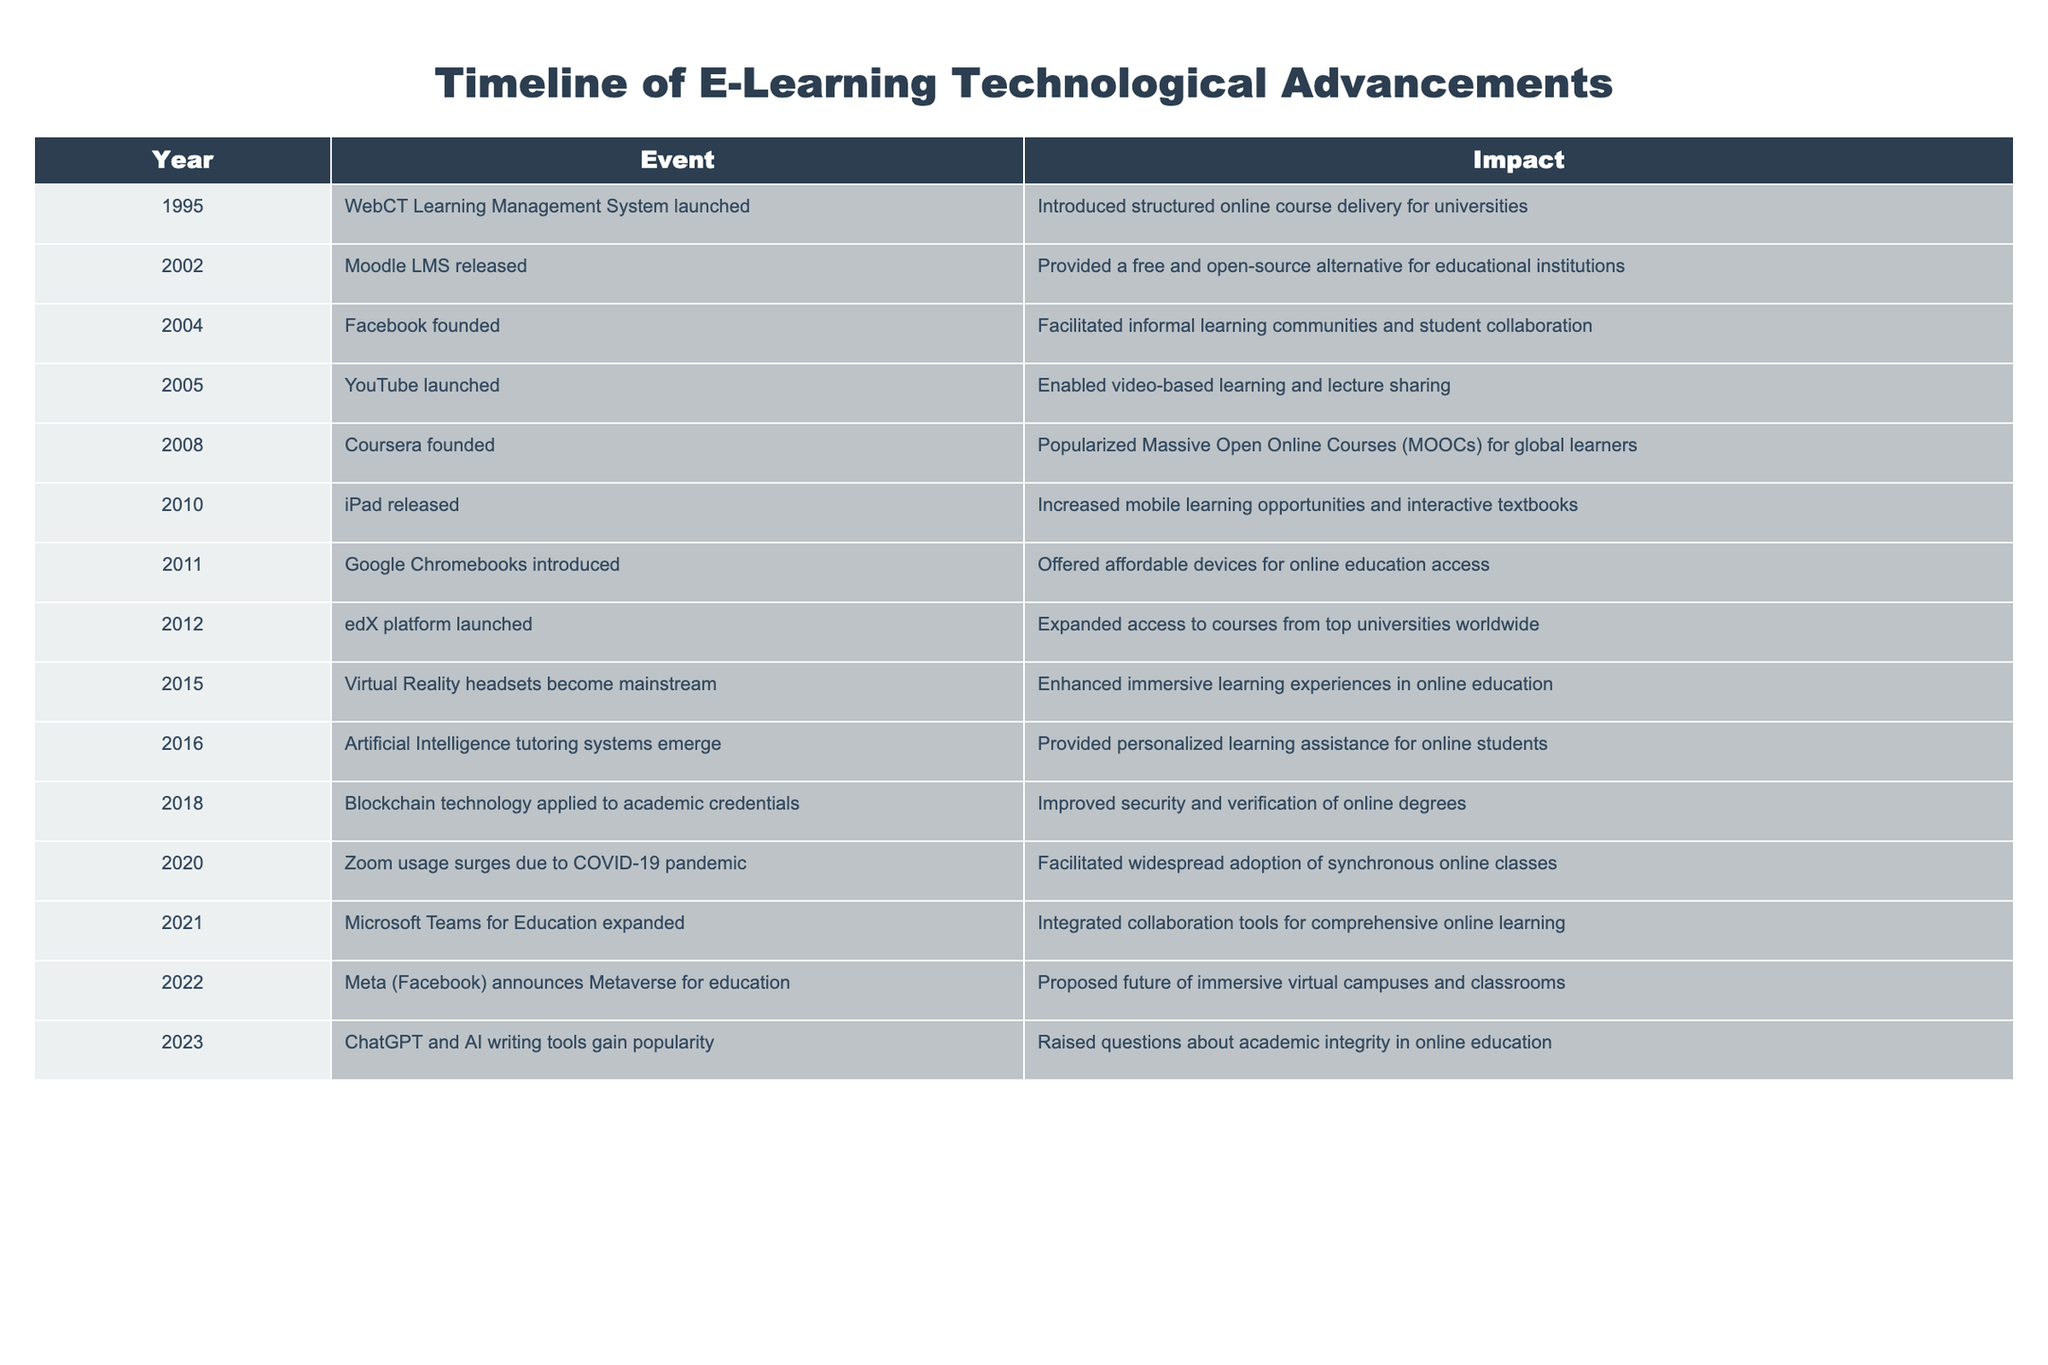What year was the WebCT Learning Management System launched? According to the table, the WebCT Learning Management System was launched in 1995. This is found in the 'Year' column where 'WebCT Learning Management System launched' appears in the 'Event' column.
Answer: 1995 Which event marked the popularization of MOOCs? The event that marked the popularization of MOOCs was the founding of Coursera in 2008. This can be identified in the year 2008, where 'Coursera founded' is listed as the event.
Answer: 2008 How many events occurred that enhanced immersive learning experiences? There are two events related to enhancing immersive learning experiences: in 2015, Virtual Reality headsets became mainstream, and in 2022, Meta announced Metaverse for education. Therefore, I count these two events listed under 'Event' in the table.
Answer: 2 Did the launch of YouTube have any impact on online education? Yes, the launch of YouTube in 2005 enabled video-based learning and lecture sharing, indicating a positive impact on online education. This is confirmed in the 'Impact' column corresponding to the 'Event' of YouTube launch.
Answer: Yes What is the range of years during which major LMS platforms were launched? Major LMS platforms were launched between 1995 (WebCT) and 2012 (edX). To calculate the range, the start year is 1995 and the end year is 2012. The range can be expressed as the difference: 2012 - 1995 = 17 years.
Answer: 17 years Which year did artificial intelligence tutoring systems emerge, and what was their impact? Artificial Intelligence tutoring systems emerged in 2016, providing personalized learning assistance for online students, as noted in the corresponding 'Impact' column for that year.
Answer: 2016, personalized learning assistance What was the primary impact of Zoom's surge in 2020? The primary impact of Zoom's surge in 2020 due to the COVID-19 pandemic was the widespread adoption of synchronous online classes, as described in the 'Impact' column for that year.
Answer: Widespread adoption of synchronous online classes What technological advancement happened immediately after the launch of the iPad in 2010? The advancement that happened immediately after the iPad was the introduction of Google Chromebooks in 2011, which offered affordable devices for online education access. This is noted in the following year row in the table.
Answer: Google Chromebooks introduced in 2011 Which technology gained popularity in 2023, and what issue did it raise? In 2023, ChatGPT and AI writing tools gained popularity, raising questions about academic integrity in online education. This information can be found in the respective ‘Event’ and ‘Impact’ columns for that year.
Answer: ChatGPT and AI writing tools, raised questions about academic integrity 